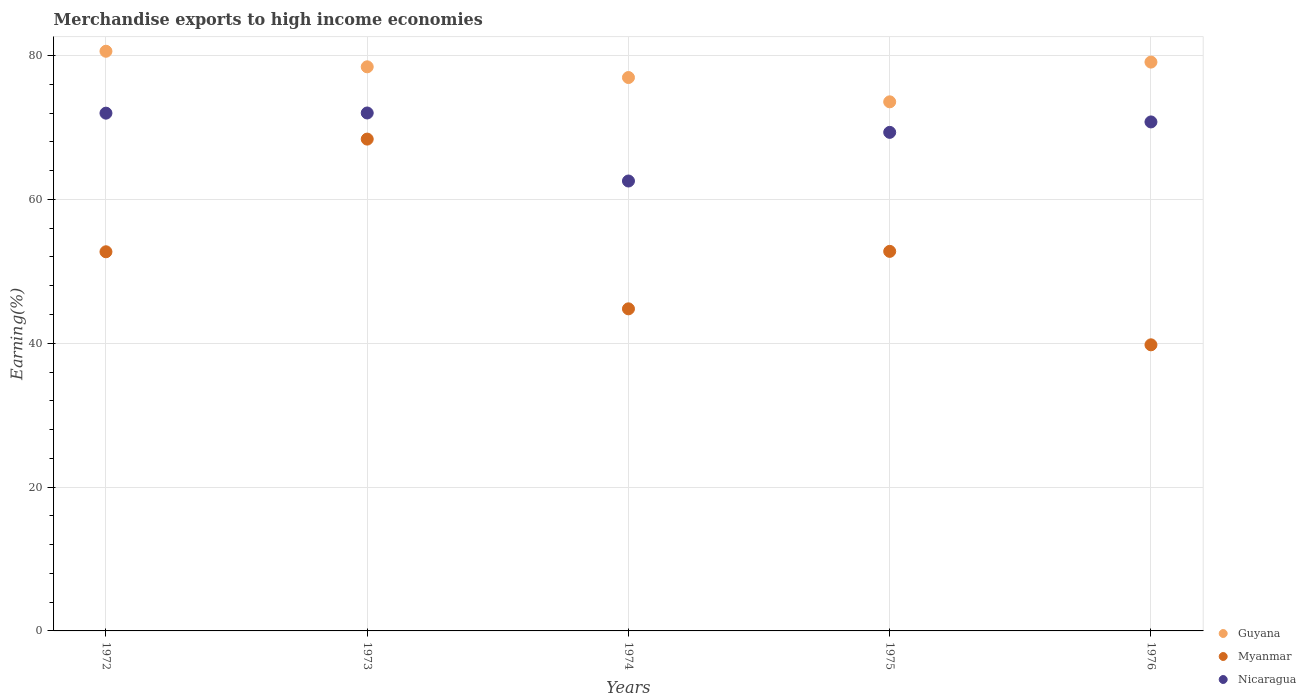Is the number of dotlines equal to the number of legend labels?
Your answer should be compact. Yes. What is the percentage of amount earned from merchandise exports in Nicaragua in 1974?
Keep it short and to the point. 62.56. Across all years, what is the maximum percentage of amount earned from merchandise exports in Myanmar?
Provide a short and direct response. 68.39. Across all years, what is the minimum percentage of amount earned from merchandise exports in Guyana?
Your response must be concise. 73.57. In which year was the percentage of amount earned from merchandise exports in Guyana maximum?
Offer a very short reply. 1972. In which year was the percentage of amount earned from merchandise exports in Guyana minimum?
Your answer should be very brief. 1975. What is the total percentage of amount earned from merchandise exports in Myanmar in the graph?
Provide a succinct answer. 258.46. What is the difference between the percentage of amount earned from merchandise exports in Guyana in 1974 and that in 1976?
Your answer should be very brief. -2.15. What is the difference between the percentage of amount earned from merchandise exports in Guyana in 1973 and the percentage of amount earned from merchandise exports in Nicaragua in 1976?
Offer a terse response. 7.66. What is the average percentage of amount earned from merchandise exports in Nicaragua per year?
Ensure brevity in your answer.  69.34. In the year 1975, what is the difference between the percentage of amount earned from merchandise exports in Myanmar and percentage of amount earned from merchandise exports in Nicaragua?
Ensure brevity in your answer.  -16.55. What is the ratio of the percentage of amount earned from merchandise exports in Myanmar in 1972 to that in 1974?
Provide a short and direct response. 1.18. Is the difference between the percentage of amount earned from merchandise exports in Myanmar in 1972 and 1975 greater than the difference between the percentage of amount earned from merchandise exports in Nicaragua in 1972 and 1975?
Make the answer very short. No. What is the difference between the highest and the second highest percentage of amount earned from merchandise exports in Nicaragua?
Your answer should be compact. 0.02. What is the difference between the highest and the lowest percentage of amount earned from merchandise exports in Guyana?
Provide a succinct answer. 7.03. Is the sum of the percentage of amount earned from merchandise exports in Nicaragua in 1972 and 1975 greater than the maximum percentage of amount earned from merchandise exports in Guyana across all years?
Offer a very short reply. Yes. Is it the case that in every year, the sum of the percentage of amount earned from merchandise exports in Guyana and percentage of amount earned from merchandise exports in Myanmar  is greater than the percentage of amount earned from merchandise exports in Nicaragua?
Your answer should be very brief. Yes. Does the percentage of amount earned from merchandise exports in Myanmar monotonically increase over the years?
Offer a very short reply. No. Is the percentage of amount earned from merchandise exports in Myanmar strictly greater than the percentage of amount earned from merchandise exports in Guyana over the years?
Your answer should be very brief. No. How many years are there in the graph?
Offer a very short reply. 5. What is the difference between two consecutive major ticks on the Y-axis?
Make the answer very short. 20. Does the graph contain grids?
Your response must be concise. Yes. Where does the legend appear in the graph?
Ensure brevity in your answer.  Bottom right. What is the title of the graph?
Offer a very short reply. Merchandise exports to high income economies. Does "Montenegro" appear as one of the legend labels in the graph?
Make the answer very short. No. What is the label or title of the X-axis?
Your response must be concise. Years. What is the label or title of the Y-axis?
Ensure brevity in your answer.  Earning(%). What is the Earning(%) in Guyana in 1972?
Ensure brevity in your answer.  80.61. What is the Earning(%) of Myanmar in 1972?
Offer a terse response. 52.72. What is the Earning(%) in Nicaragua in 1972?
Your answer should be compact. 72. What is the Earning(%) in Guyana in 1973?
Make the answer very short. 78.44. What is the Earning(%) in Myanmar in 1973?
Offer a very short reply. 68.39. What is the Earning(%) of Nicaragua in 1973?
Your response must be concise. 72.02. What is the Earning(%) of Guyana in 1974?
Provide a short and direct response. 76.95. What is the Earning(%) of Myanmar in 1974?
Your response must be concise. 44.79. What is the Earning(%) in Nicaragua in 1974?
Provide a short and direct response. 62.56. What is the Earning(%) in Guyana in 1975?
Offer a terse response. 73.57. What is the Earning(%) of Myanmar in 1975?
Your answer should be very brief. 52.78. What is the Earning(%) in Nicaragua in 1975?
Make the answer very short. 69.33. What is the Earning(%) in Guyana in 1976?
Offer a very short reply. 79.1. What is the Earning(%) in Myanmar in 1976?
Make the answer very short. 39.78. What is the Earning(%) of Nicaragua in 1976?
Your response must be concise. 70.78. Across all years, what is the maximum Earning(%) in Guyana?
Offer a terse response. 80.61. Across all years, what is the maximum Earning(%) of Myanmar?
Your answer should be compact. 68.39. Across all years, what is the maximum Earning(%) of Nicaragua?
Make the answer very short. 72.02. Across all years, what is the minimum Earning(%) in Guyana?
Your response must be concise. 73.57. Across all years, what is the minimum Earning(%) in Myanmar?
Give a very brief answer. 39.78. Across all years, what is the minimum Earning(%) of Nicaragua?
Provide a succinct answer. 62.56. What is the total Earning(%) in Guyana in the graph?
Offer a terse response. 388.67. What is the total Earning(%) in Myanmar in the graph?
Provide a succinct answer. 258.46. What is the total Earning(%) of Nicaragua in the graph?
Provide a succinct answer. 346.69. What is the difference between the Earning(%) in Guyana in 1972 and that in 1973?
Keep it short and to the point. 2.16. What is the difference between the Earning(%) of Myanmar in 1972 and that in 1973?
Give a very brief answer. -15.67. What is the difference between the Earning(%) in Nicaragua in 1972 and that in 1973?
Offer a very short reply. -0.02. What is the difference between the Earning(%) in Guyana in 1972 and that in 1974?
Your answer should be compact. 3.65. What is the difference between the Earning(%) in Myanmar in 1972 and that in 1974?
Provide a short and direct response. 7.93. What is the difference between the Earning(%) in Nicaragua in 1972 and that in 1974?
Give a very brief answer. 9.44. What is the difference between the Earning(%) of Guyana in 1972 and that in 1975?
Your answer should be very brief. 7.03. What is the difference between the Earning(%) in Myanmar in 1972 and that in 1975?
Ensure brevity in your answer.  -0.06. What is the difference between the Earning(%) in Nicaragua in 1972 and that in 1975?
Provide a succinct answer. 2.67. What is the difference between the Earning(%) of Guyana in 1972 and that in 1976?
Ensure brevity in your answer.  1.51. What is the difference between the Earning(%) in Myanmar in 1972 and that in 1976?
Provide a succinct answer. 12.94. What is the difference between the Earning(%) in Nicaragua in 1972 and that in 1976?
Provide a short and direct response. 1.22. What is the difference between the Earning(%) in Guyana in 1973 and that in 1974?
Your response must be concise. 1.49. What is the difference between the Earning(%) in Myanmar in 1973 and that in 1974?
Give a very brief answer. 23.6. What is the difference between the Earning(%) in Nicaragua in 1973 and that in 1974?
Provide a succinct answer. 9.46. What is the difference between the Earning(%) in Guyana in 1973 and that in 1975?
Your answer should be compact. 4.87. What is the difference between the Earning(%) in Myanmar in 1973 and that in 1975?
Give a very brief answer. 15.61. What is the difference between the Earning(%) of Nicaragua in 1973 and that in 1975?
Provide a short and direct response. 2.69. What is the difference between the Earning(%) of Guyana in 1973 and that in 1976?
Provide a succinct answer. -0.66. What is the difference between the Earning(%) of Myanmar in 1973 and that in 1976?
Provide a succinct answer. 28.61. What is the difference between the Earning(%) of Nicaragua in 1973 and that in 1976?
Your answer should be very brief. 1.24. What is the difference between the Earning(%) of Guyana in 1974 and that in 1975?
Your answer should be compact. 3.38. What is the difference between the Earning(%) in Myanmar in 1974 and that in 1975?
Make the answer very short. -7.99. What is the difference between the Earning(%) of Nicaragua in 1974 and that in 1975?
Your answer should be very brief. -6.77. What is the difference between the Earning(%) in Guyana in 1974 and that in 1976?
Your response must be concise. -2.15. What is the difference between the Earning(%) in Myanmar in 1974 and that in 1976?
Ensure brevity in your answer.  5. What is the difference between the Earning(%) in Nicaragua in 1974 and that in 1976?
Your response must be concise. -8.22. What is the difference between the Earning(%) in Guyana in 1975 and that in 1976?
Provide a short and direct response. -5.52. What is the difference between the Earning(%) of Myanmar in 1975 and that in 1976?
Your answer should be very brief. 13. What is the difference between the Earning(%) in Nicaragua in 1975 and that in 1976?
Ensure brevity in your answer.  -1.45. What is the difference between the Earning(%) in Guyana in 1972 and the Earning(%) in Myanmar in 1973?
Offer a terse response. 12.22. What is the difference between the Earning(%) in Guyana in 1972 and the Earning(%) in Nicaragua in 1973?
Your answer should be very brief. 8.58. What is the difference between the Earning(%) of Myanmar in 1972 and the Earning(%) of Nicaragua in 1973?
Provide a succinct answer. -19.3. What is the difference between the Earning(%) of Guyana in 1972 and the Earning(%) of Myanmar in 1974?
Offer a very short reply. 35.82. What is the difference between the Earning(%) in Guyana in 1972 and the Earning(%) in Nicaragua in 1974?
Give a very brief answer. 18.04. What is the difference between the Earning(%) of Myanmar in 1972 and the Earning(%) of Nicaragua in 1974?
Provide a short and direct response. -9.84. What is the difference between the Earning(%) of Guyana in 1972 and the Earning(%) of Myanmar in 1975?
Provide a short and direct response. 27.83. What is the difference between the Earning(%) in Guyana in 1972 and the Earning(%) in Nicaragua in 1975?
Offer a very short reply. 11.28. What is the difference between the Earning(%) of Myanmar in 1972 and the Earning(%) of Nicaragua in 1975?
Give a very brief answer. -16.61. What is the difference between the Earning(%) of Guyana in 1972 and the Earning(%) of Myanmar in 1976?
Your response must be concise. 40.82. What is the difference between the Earning(%) of Guyana in 1972 and the Earning(%) of Nicaragua in 1976?
Keep it short and to the point. 9.83. What is the difference between the Earning(%) in Myanmar in 1972 and the Earning(%) in Nicaragua in 1976?
Offer a very short reply. -18.06. What is the difference between the Earning(%) of Guyana in 1973 and the Earning(%) of Myanmar in 1974?
Your response must be concise. 33.65. What is the difference between the Earning(%) of Guyana in 1973 and the Earning(%) of Nicaragua in 1974?
Provide a short and direct response. 15.88. What is the difference between the Earning(%) of Myanmar in 1973 and the Earning(%) of Nicaragua in 1974?
Offer a very short reply. 5.83. What is the difference between the Earning(%) in Guyana in 1973 and the Earning(%) in Myanmar in 1975?
Offer a terse response. 25.66. What is the difference between the Earning(%) in Guyana in 1973 and the Earning(%) in Nicaragua in 1975?
Your response must be concise. 9.11. What is the difference between the Earning(%) in Myanmar in 1973 and the Earning(%) in Nicaragua in 1975?
Offer a terse response. -0.94. What is the difference between the Earning(%) of Guyana in 1973 and the Earning(%) of Myanmar in 1976?
Your response must be concise. 38.66. What is the difference between the Earning(%) in Guyana in 1973 and the Earning(%) in Nicaragua in 1976?
Provide a succinct answer. 7.66. What is the difference between the Earning(%) in Myanmar in 1973 and the Earning(%) in Nicaragua in 1976?
Offer a terse response. -2.39. What is the difference between the Earning(%) of Guyana in 1974 and the Earning(%) of Myanmar in 1975?
Your answer should be very brief. 24.17. What is the difference between the Earning(%) in Guyana in 1974 and the Earning(%) in Nicaragua in 1975?
Offer a very short reply. 7.62. What is the difference between the Earning(%) of Myanmar in 1974 and the Earning(%) of Nicaragua in 1975?
Offer a terse response. -24.54. What is the difference between the Earning(%) in Guyana in 1974 and the Earning(%) in Myanmar in 1976?
Keep it short and to the point. 37.17. What is the difference between the Earning(%) in Guyana in 1974 and the Earning(%) in Nicaragua in 1976?
Give a very brief answer. 6.17. What is the difference between the Earning(%) in Myanmar in 1974 and the Earning(%) in Nicaragua in 1976?
Offer a terse response. -25.99. What is the difference between the Earning(%) in Guyana in 1975 and the Earning(%) in Myanmar in 1976?
Your answer should be compact. 33.79. What is the difference between the Earning(%) of Guyana in 1975 and the Earning(%) of Nicaragua in 1976?
Provide a succinct answer. 2.8. What is the difference between the Earning(%) in Myanmar in 1975 and the Earning(%) in Nicaragua in 1976?
Make the answer very short. -18. What is the average Earning(%) in Guyana per year?
Ensure brevity in your answer.  77.73. What is the average Earning(%) of Myanmar per year?
Keep it short and to the point. 51.69. What is the average Earning(%) of Nicaragua per year?
Your response must be concise. 69.34. In the year 1972, what is the difference between the Earning(%) in Guyana and Earning(%) in Myanmar?
Keep it short and to the point. 27.88. In the year 1972, what is the difference between the Earning(%) of Guyana and Earning(%) of Nicaragua?
Provide a short and direct response. 8.61. In the year 1972, what is the difference between the Earning(%) of Myanmar and Earning(%) of Nicaragua?
Your answer should be compact. -19.28. In the year 1973, what is the difference between the Earning(%) of Guyana and Earning(%) of Myanmar?
Give a very brief answer. 10.05. In the year 1973, what is the difference between the Earning(%) in Guyana and Earning(%) in Nicaragua?
Your answer should be very brief. 6.42. In the year 1973, what is the difference between the Earning(%) in Myanmar and Earning(%) in Nicaragua?
Your answer should be very brief. -3.63. In the year 1974, what is the difference between the Earning(%) in Guyana and Earning(%) in Myanmar?
Your answer should be very brief. 32.16. In the year 1974, what is the difference between the Earning(%) in Guyana and Earning(%) in Nicaragua?
Provide a short and direct response. 14.39. In the year 1974, what is the difference between the Earning(%) of Myanmar and Earning(%) of Nicaragua?
Give a very brief answer. -17.77. In the year 1975, what is the difference between the Earning(%) of Guyana and Earning(%) of Myanmar?
Your answer should be very brief. 20.8. In the year 1975, what is the difference between the Earning(%) in Guyana and Earning(%) in Nicaragua?
Your answer should be very brief. 4.25. In the year 1975, what is the difference between the Earning(%) of Myanmar and Earning(%) of Nicaragua?
Your answer should be very brief. -16.55. In the year 1976, what is the difference between the Earning(%) of Guyana and Earning(%) of Myanmar?
Your answer should be compact. 39.31. In the year 1976, what is the difference between the Earning(%) of Guyana and Earning(%) of Nicaragua?
Keep it short and to the point. 8.32. In the year 1976, what is the difference between the Earning(%) in Myanmar and Earning(%) in Nicaragua?
Provide a short and direct response. -30.99. What is the ratio of the Earning(%) in Guyana in 1972 to that in 1973?
Ensure brevity in your answer.  1.03. What is the ratio of the Earning(%) of Myanmar in 1972 to that in 1973?
Your answer should be compact. 0.77. What is the ratio of the Earning(%) in Nicaragua in 1972 to that in 1973?
Ensure brevity in your answer.  1. What is the ratio of the Earning(%) of Guyana in 1972 to that in 1974?
Your response must be concise. 1.05. What is the ratio of the Earning(%) in Myanmar in 1972 to that in 1974?
Keep it short and to the point. 1.18. What is the ratio of the Earning(%) in Nicaragua in 1972 to that in 1974?
Your answer should be compact. 1.15. What is the ratio of the Earning(%) in Guyana in 1972 to that in 1975?
Your response must be concise. 1.1. What is the ratio of the Earning(%) of Myanmar in 1972 to that in 1975?
Offer a very short reply. 1. What is the ratio of the Earning(%) in Guyana in 1972 to that in 1976?
Your response must be concise. 1.02. What is the ratio of the Earning(%) of Myanmar in 1972 to that in 1976?
Provide a short and direct response. 1.33. What is the ratio of the Earning(%) of Nicaragua in 1972 to that in 1976?
Provide a succinct answer. 1.02. What is the ratio of the Earning(%) of Guyana in 1973 to that in 1974?
Your answer should be compact. 1.02. What is the ratio of the Earning(%) of Myanmar in 1973 to that in 1974?
Offer a terse response. 1.53. What is the ratio of the Earning(%) in Nicaragua in 1973 to that in 1974?
Offer a terse response. 1.15. What is the ratio of the Earning(%) in Guyana in 1973 to that in 1975?
Offer a terse response. 1.07. What is the ratio of the Earning(%) in Myanmar in 1973 to that in 1975?
Offer a terse response. 1.3. What is the ratio of the Earning(%) in Nicaragua in 1973 to that in 1975?
Your response must be concise. 1.04. What is the ratio of the Earning(%) of Guyana in 1973 to that in 1976?
Keep it short and to the point. 0.99. What is the ratio of the Earning(%) in Myanmar in 1973 to that in 1976?
Your answer should be compact. 1.72. What is the ratio of the Earning(%) in Nicaragua in 1973 to that in 1976?
Your answer should be compact. 1.02. What is the ratio of the Earning(%) of Guyana in 1974 to that in 1975?
Keep it short and to the point. 1.05. What is the ratio of the Earning(%) in Myanmar in 1974 to that in 1975?
Your answer should be compact. 0.85. What is the ratio of the Earning(%) of Nicaragua in 1974 to that in 1975?
Ensure brevity in your answer.  0.9. What is the ratio of the Earning(%) of Guyana in 1974 to that in 1976?
Keep it short and to the point. 0.97. What is the ratio of the Earning(%) in Myanmar in 1974 to that in 1976?
Offer a very short reply. 1.13. What is the ratio of the Earning(%) of Nicaragua in 1974 to that in 1976?
Offer a very short reply. 0.88. What is the ratio of the Earning(%) of Guyana in 1975 to that in 1976?
Give a very brief answer. 0.93. What is the ratio of the Earning(%) in Myanmar in 1975 to that in 1976?
Your answer should be compact. 1.33. What is the ratio of the Earning(%) in Nicaragua in 1975 to that in 1976?
Your answer should be very brief. 0.98. What is the difference between the highest and the second highest Earning(%) in Guyana?
Offer a terse response. 1.51. What is the difference between the highest and the second highest Earning(%) of Myanmar?
Offer a terse response. 15.61. What is the difference between the highest and the second highest Earning(%) in Nicaragua?
Offer a terse response. 0.02. What is the difference between the highest and the lowest Earning(%) in Guyana?
Give a very brief answer. 7.03. What is the difference between the highest and the lowest Earning(%) of Myanmar?
Your response must be concise. 28.61. What is the difference between the highest and the lowest Earning(%) of Nicaragua?
Offer a very short reply. 9.46. 